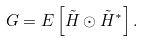<formula> <loc_0><loc_0><loc_500><loc_500>{ G } = E \left [ { { \tilde { H } } \odot { \tilde { H } } ^ { * } } \right ] .</formula> 